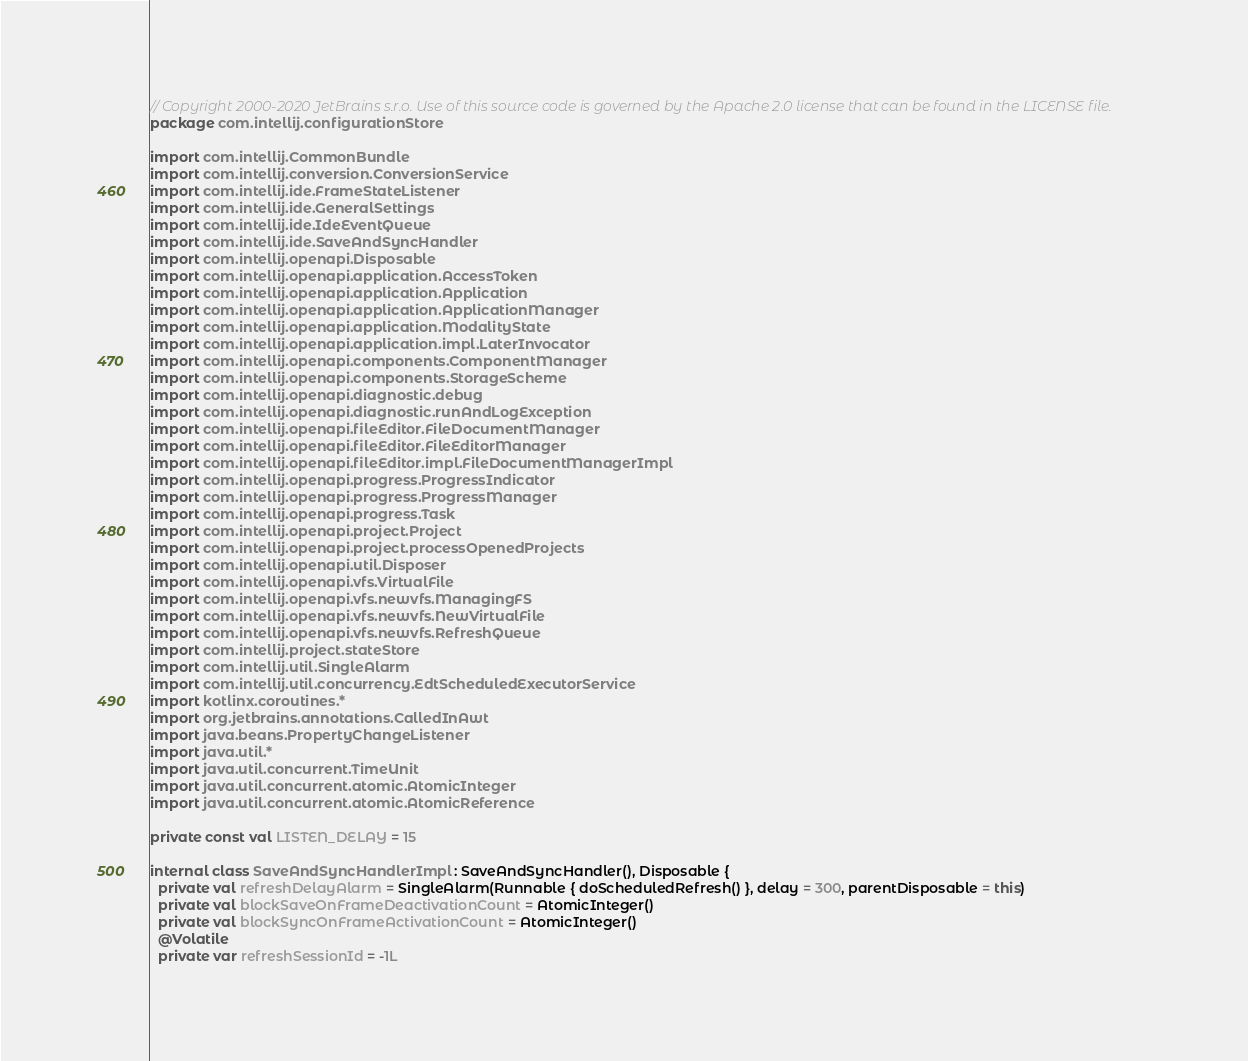Convert code to text. <code><loc_0><loc_0><loc_500><loc_500><_Kotlin_>// Copyright 2000-2020 JetBrains s.r.o. Use of this source code is governed by the Apache 2.0 license that can be found in the LICENSE file.
package com.intellij.configurationStore

import com.intellij.CommonBundle
import com.intellij.conversion.ConversionService
import com.intellij.ide.FrameStateListener
import com.intellij.ide.GeneralSettings
import com.intellij.ide.IdeEventQueue
import com.intellij.ide.SaveAndSyncHandler
import com.intellij.openapi.Disposable
import com.intellij.openapi.application.AccessToken
import com.intellij.openapi.application.Application
import com.intellij.openapi.application.ApplicationManager
import com.intellij.openapi.application.ModalityState
import com.intellij.openapi.application.impl.LaterInvocator
import com.intellij.openapi.components.ComponentManager
import com.intellij.openapi.components.StorageScheme
import com.intellij.openapi.diagnostic.debug
import com.intellij.openapi.diagnostic.runAndLogException
import com.intellij.openapi.fileEditor.FileDocumentManager
import com.intellij.openapi.fileEditor.FileEditorManager
import com.intellij.openapi.fileEditor.impl.FileDocumentManagerImpl
import com.intellij.openapi.progress.ProgressIndicator
import com.intellij.openapi.progress.ProgressManager
import com.intellij.openapi.progress.Task
import com.intellij.openapi.project.Project
import com.intellij.openapi.project.processOpenedProjects
import com.intellij.openapi.util.Disposer
import com.intellij.openapi.vfs.VirtualFile
import com.intellij.openapi.vfs.newvfs.ManagingFS
import com.intellij.openapi.vfs.newvfs.NewVirtualFile
import com.intellij.openapi.vfs.newvfs.RefreshQueue
import com.intellij.project.stateStore
import com.intellij.util.SingleAlarm
import com.intellij.util.concurrency.EdtScheduledExecutorService
import kotlinx.coroutines.*
import org.jetbrains.annotations.CalledInAwt
import java.beans.PropertyChangeListener
import java.util.*
import java.util.concurrent.TimeUnit
import java.util.concurrent.atomic.AtomicInteger
import java.util.concurrent.atomic.AtomicReference

private const val LISTEN_DELAY = 15

internal class SaveAndSyncHandlerImpl : SaveAndSyncHandler(), Disposable {
  private val refreshDelayAlarm = SingleAlarm(Runnable { doScheduledRefresh() }, delay = 300, parentDisposable = this)
  private val blockSaveOnFrameDeactivationCount = AtomicInteger()
  private val blockSyncOnFrameActivationCount = AtomicInteger()
  @Volatile
  private var refreshSessionId = -1L
</code> 